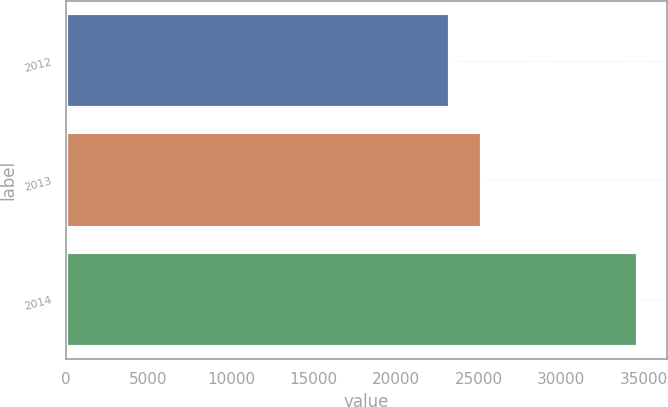Convert chart to OTSL. <chart><loc_0><loc_0><loc_500><loc_500><bar_chart><fcel>2012<fcel>2013<fcel>2014<nl><fcel>23277<fcel>25209<fcel>34645<nl></chart> 